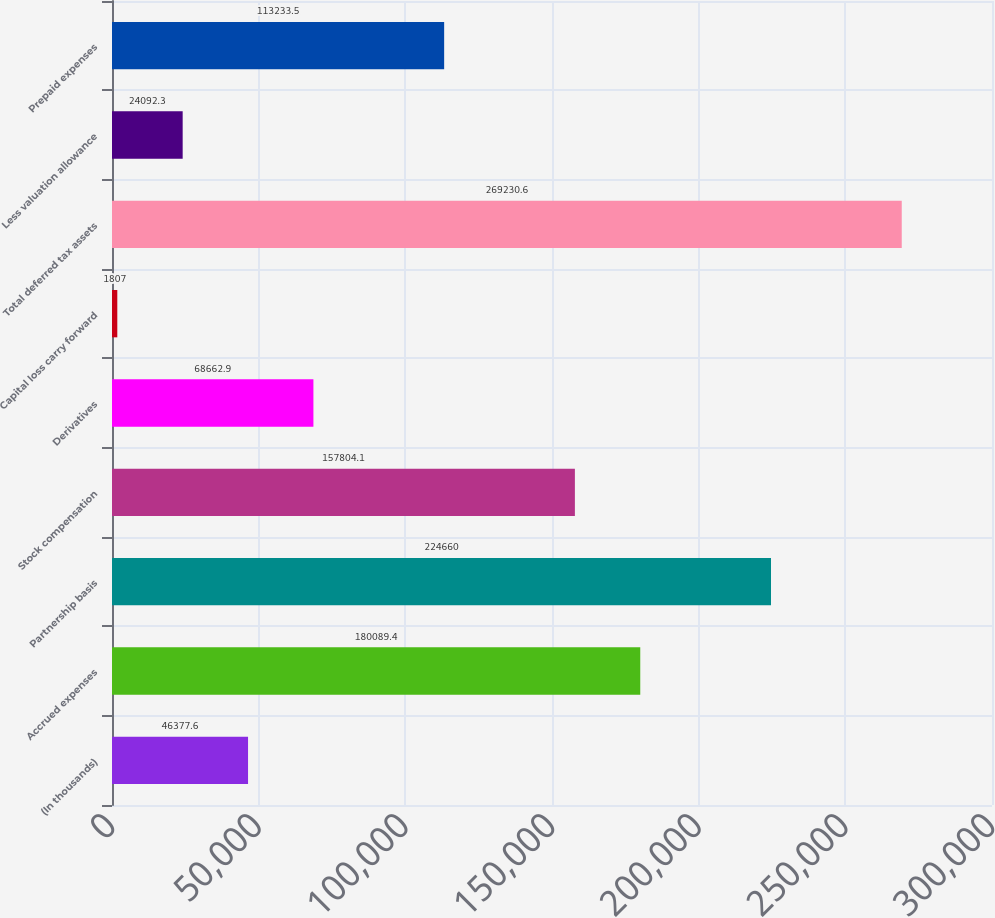<chart> <loc_0><loc_0><loc_500><loc_500><bar_chart><fcel>(In thousands)<fcel>Accrued expenses<fcel>Partnership basis<fcel>Stock compensation<fcel>Derivatives<fcel>Capital loss carry forward<fcel>Total deferred tax assets<fcel>Less valuation allowance<fcel>Prepaid expenses<nl><fcel>46377.6<fcel>180089<fcel>224660<fcel>157804<fcel>68662.9<fcel>1807<fcel>269231<fcel>24092.3<fcel>113234<nl></chart> 